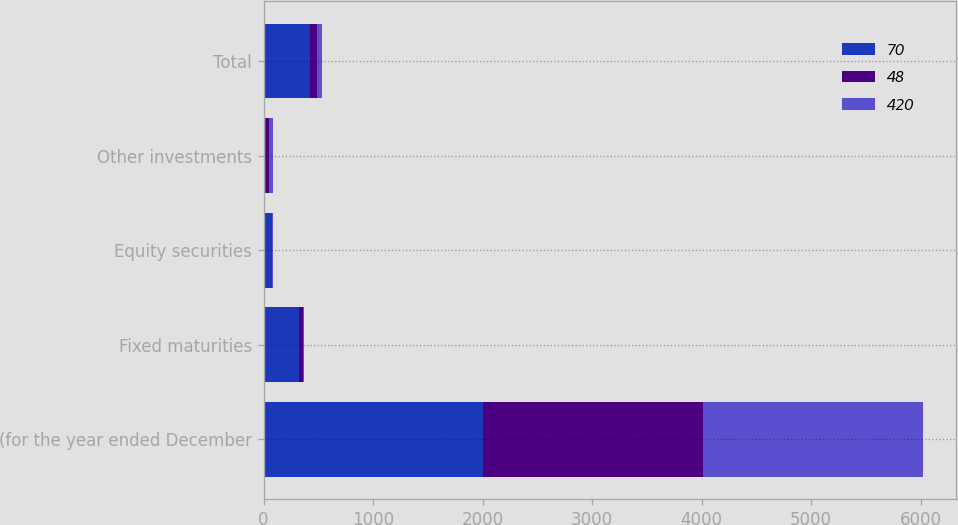<chart> <loc_0><loc_0><loc_500><loc_500><stacked_bar_chart><ecel><fcel>(for the year ended December<fcel>Fixed maturities<fcel>Equity securities<fcel>Other investments<fcel>Total<nl><fcel>70<fcel>2008<fcel>324<fcel>74<fcel>22<fcel>420<nl><fcel>48<fcel>2007<fcel>37<fcel>7<fcel>26<fcel>70<nl><fcel>420<fcel>2006<fcel>7<fcel>4<fcel>37<fcel>48<nl></chart> 